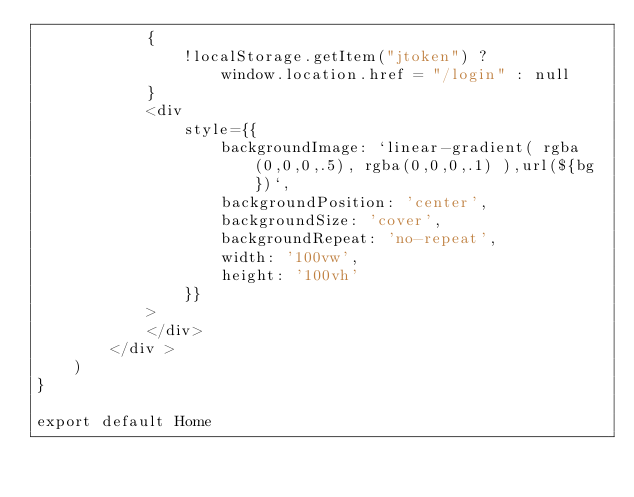<code> <loc_0><loc_0><loc_500><loc_500><_JavaScript_>            {
                !localStorage.getItem("jtoken") ?
                    window.location.href = "/login" : null
            }
            <div
                style={{
                    backgroundImage: `linear-gradient( rgba(0,0,0,.5), rgba(0,0,0,.1) ),url(${bg})`,
                    backgroundPosition: 'center',
                    backgroundSize: 'cover',
                    backgroundRepeat: 'no-repeat',
                    width: '100vw',
                    height: '100vh'
                }}
            >
            </div>
        </div >
    )
}

export default Home
</code> 